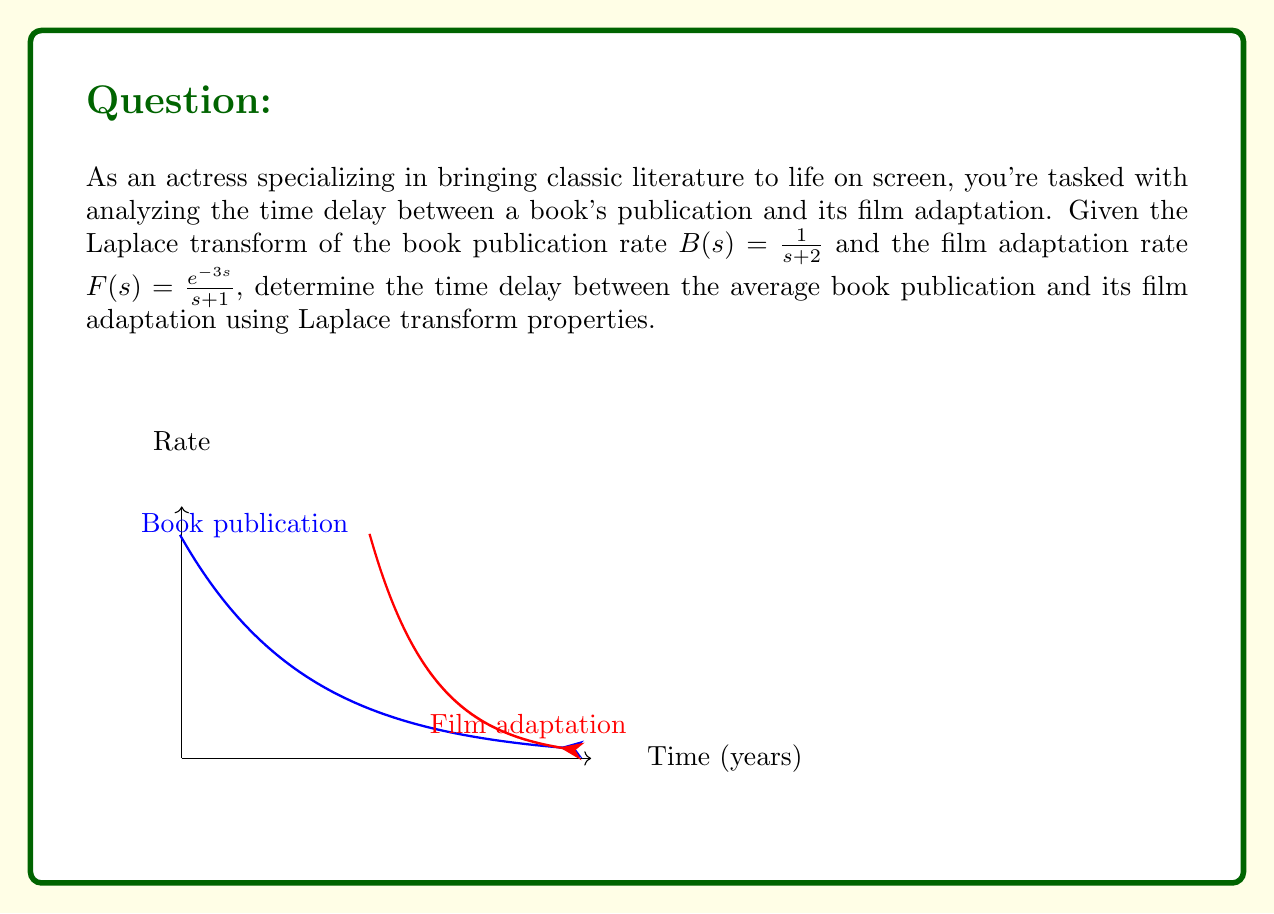Can you answer this question? To solve this problem, we'll use the following steps:

1) The time delay in the Laplace domain is represented by the $e^{-3s}$ term in $F(s)$. This indicates a 3-year delay between book publication and film adaptation.

2) To find the average time for book publication, we need to calculate the mean or expected value of the exponential distribution represented by $B(s)$:

   $$E[T_B] = -\frac{d}{ds}B(s)\bigg|_{s=0} = -\frac{d}{ds}\left(\frac{1}{s+2}\right)\bigg|_{s=0} = \frac{1}{(s+2)^2}\bigg|_{s=0} = \frac{1}{4}$$

3) Similarly, for the film adaptation (ignoring the delay):

   $$E[T_F] = -\frac{d}{ds}\left(\frac{1}{s+1}\right)\bigg|_{s=0} = \frac{1}{(s+1)^2}\bigg|_{s=0} = 1$$

4) The total time delay is the sum of the 3-year fixed delay and the difference between the average film adaptation time and the average book publication time:

   $$\text{Total Delay} = 3 + (E[T_F] - E[T_B]) = 3 + (1 - \frac{1}{4}) = 3 + \frac{3}{4} = \frac{15}{4}$$
Answer: $\frac{15}{4}$ years 